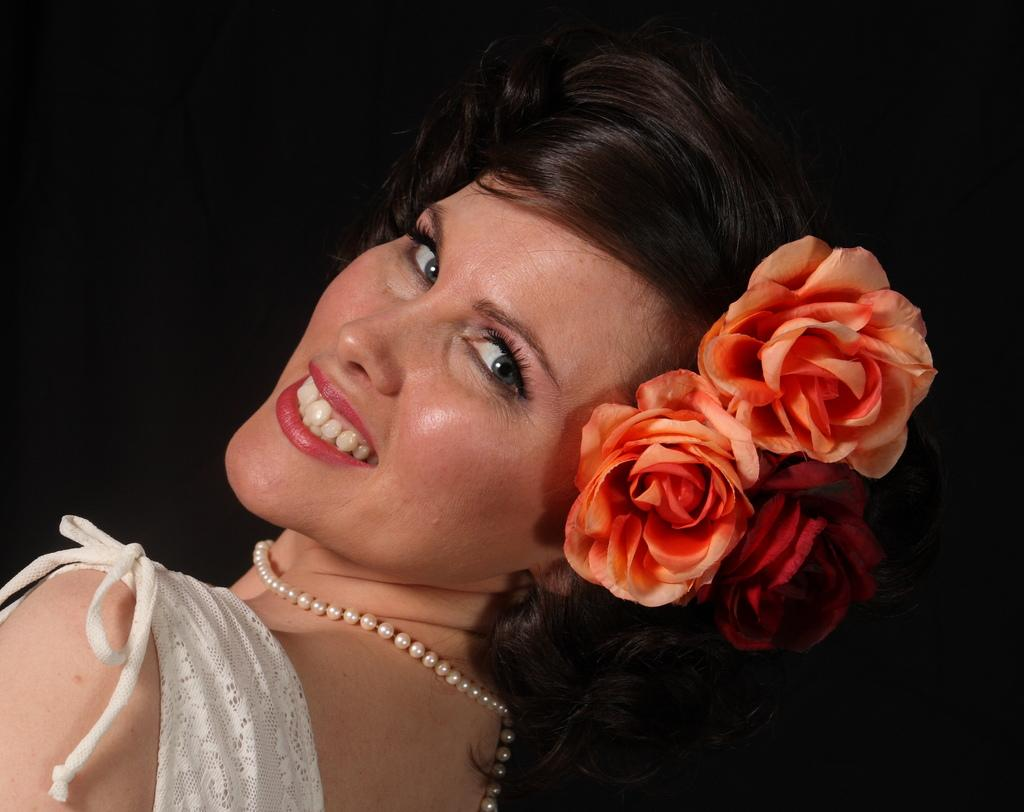Who is present in the image? There is a person in the image. What is the person wearing? The person is wearing a white dress. What type of flowers can be seen in the image? There are orange-colored flowers in the image. How would you describe the background of the image? The background of the image is dark. Can you see a snail crawling along the line of orange-colored flowers in the image? There is no snail or line present in the image; it features a person wearing a white dress and orange-colored flowers in a dark background. 